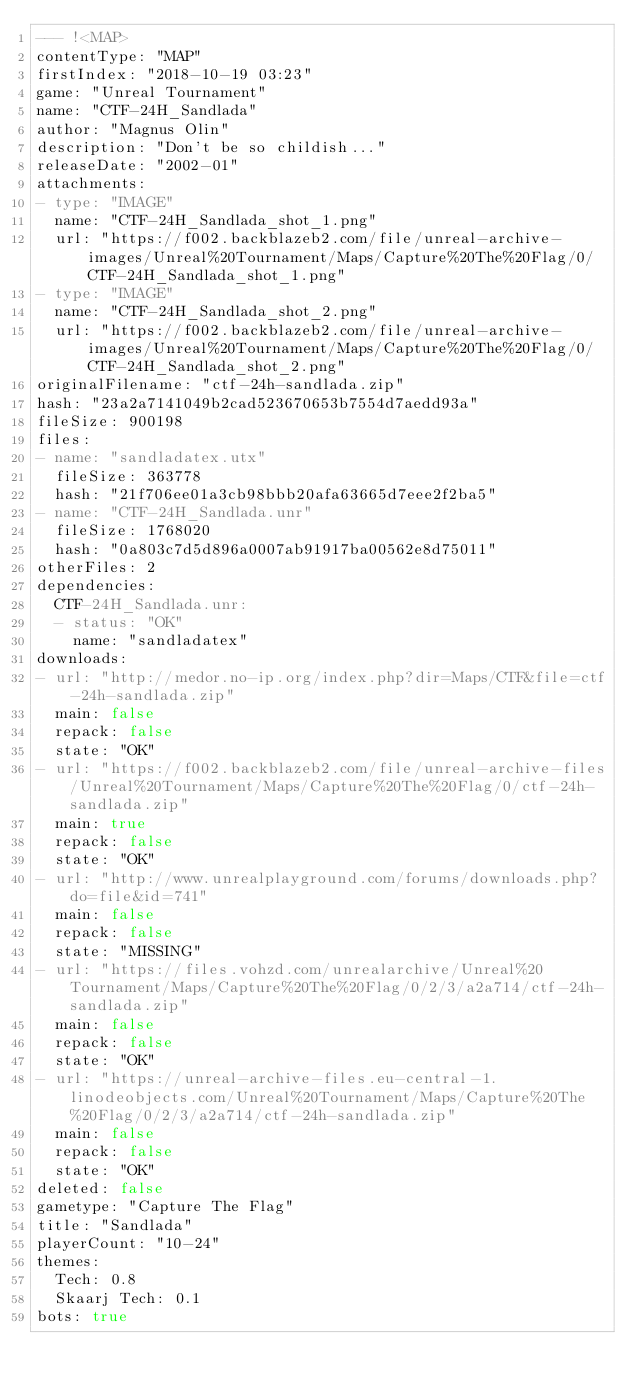Convert code to text. <code><loc_0><loc_0><loc_500><loc_500><_YAML_>--- !<MAP>
contentType: "MAP"
firstIndex: "2018-10-19 03:23"
game: "Unreal Tournament"
name: "CTF-24H_Sandlada"
author: "Magnus Olin"
description: "Don't be so childish..."
releaseDate: "2002-01"
attachments:
- type: "IMAGE"
  name: "CTF-24H_Sandlada_shot_1.png"
  url: "https://f002.backblazeb2.com/file/unreal-archive-images/Unreal%20Tournament/Maps/Capture%20The%20Flag/0/CTF-24H_Sandlada_shot_1.png"
- type: "IMAGE"
  name: "CTF-24H_Sandlada_shot_2.png"
  url: "https://f002.backblazeb2.com/file/unreal-archive-images/Unreal%20Tournament/Maps/Capture%20The%20Flag/0/CTF-24H_Sandlada_shot_2.png"
originalFilename: "ctf-24h-sandlada.zip"
hash: "23a2a7141049b2cad523670653b7554d7aedd93a"
fileSize: 900198
files:
- name: "sandladatex.utx"
  fileSize: 363778
  hash: "21f706ee01a3cb98bbb20afa63665d7eee2f2ba5"
- name: "CTF-24H_Sandlada.unr"
  fileSize: 1768020
  hash: "0a803c7d5d896a0007ab91917ba00562e8d75011"
otherFiles: 2
dependencies:
  CTF-24H_Sandlada.unr:
  - status: "OK"
    name: "sandladatex"
downloads:
- url: "http://medor.no-ip.org/index.php?dir=Maps/CTF&file=ctf-24h-sandlada.zip"
  main: false
  repack: false
  state: "OK"
- url: "https://f002.backblazeb2.com/file/unreal-archive-files/Unreal%20Tournament/Maps/Capture%20The%20Flag/0/ctf-24h-sandlada.zip"
  main: true
  repack: false
  state: "OK"
- url: "http://www.unrealplayground.com/forums/downloads.php?do=file&id=741"
  main: false
  repack: false
  state: "MISSING"
- url: "https://files.vohzd.com/unrealarchive/Unreal%20Tournament/Maps/Capture%20The%20Flag/0/2/3/a2a714/ctf-24h-sandlada.zip"
  main: false
  repack: false
  state: "OK"
- url: "https://unreal-archive-files.eu-central-1.linodeobjects.com/Unreal%20Tournament/Maps/Capture%20The%20Flag/0/2/3/a2a714/ctf-24h-sandlada.zip"
  main: false
  repack: false
  state: "OK"
deleted: false
gametype: "Capture The Flag"
title: "Sandlada"
playerCount: "10-24"
themes:
  Tech: 0.8
  Skaarj Tech: 0.1
bots: true
</code> 